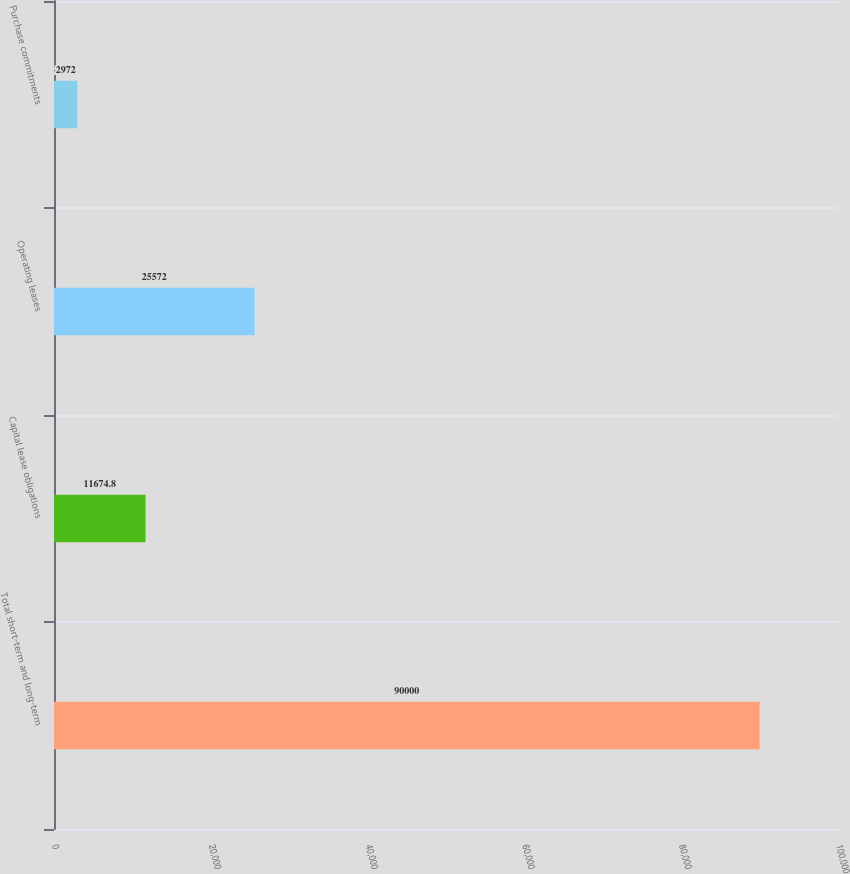<chart> <loc_0><loc_0><loc_500><loc_500><bar_chart><fcel>Total short-term and long-term<fcel>Capital lease obligations<fcel>Operating leases<fcel>Purchase commitments<nl><fcel>90000<fcel>11674.8<fcel>25572<fcel>2972<nl></chart> 